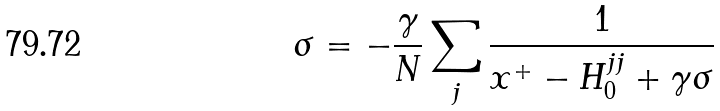<formula> <loc_0><loc_0><loc_500><loc_500>\sigma = - \frac { \gamma } { N } \sum _ { j } \frac { 1 } { x ^ { + } - H _ { 0 } ^ { j j } + \gamma \sigma }</formula> 